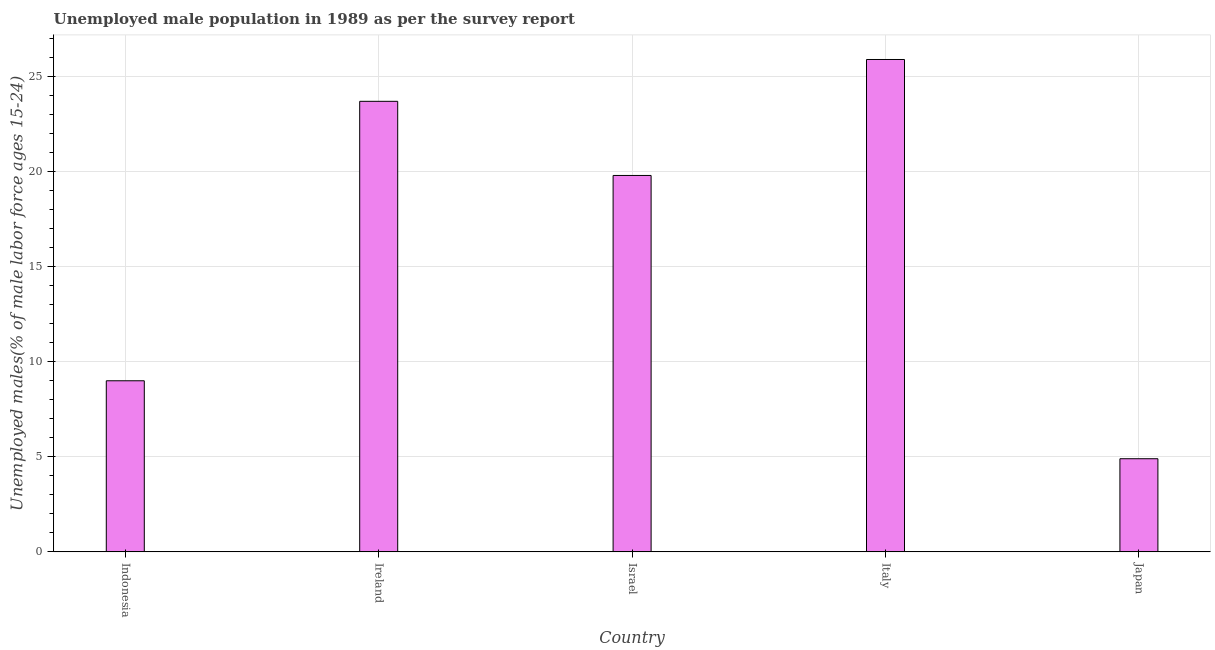Does the graph contain any zero values?
Offer a terse response. No. What is the title of the graph?
Provide a short and direct response. Unemployed male population in 1989 as per the survey report. What is the label or title of the X-axis?
Your response must be concise. Country. What is the label or title of the Y-axis?
Make the answer very short. Unemployed males(% of male labor force ages 15-24). Across all countries, what is the maximum unemployed male youth?
Offer a terse response. 25.9. Across all countries, what is the minimum unemployed male youth?
Give a very brief answer. 4.9. In which country was the unemployed male youth maximum?
Your answer should be compact. Italy. In which country was the unemployed male youth minimum?
Make the answer very short. Japan. What is the sum of the unemployed male youth?
Provide a short and direct response. 83.3. What is the difference between the unemployed male youth in Israel and Italy?
Make the answer very short. -6.1. What is the average unemployed male youth per country?
Offer a very short reply. 16.66. What is the median unemployed male youth?
Make the answer very short. 19.8. What is the ratio of the unemployed male youth in Israel to that in Japan?
Provide a short and direct response. 4.04. Is the unemployed male youth in Ireland less than that in Israel?
Offer a very short reply. No. What is the difference between the highest and the second highest unemployed male youth?
Give a very brief answer. 2.2. In how many countries, is the unemployed male youth greater than the average unemployed male youth taken over all countries?
Provide a succinct answer. 3. How many countries are there in the graph?
Offer a very short reply. 5. What is the Unemployed males(% of male labor force ages 15-24) in Indonesia?
Your answer should be very brief. 9. What is the Unemployed males(% of male labor force ages 15-24) of Ireland?
Offer a terse response. 23.7. What is the Unemployed males(% of male labor force ages 15-24) of Israel?
Provide a short and direct response. 19.8. What is the Unemployed males(% of male labor force ages 15-24) of Italy?
Provide a short and direct response. 25.9. What is the Unemployed males(% of male labor force ages 15-24) in Japan?
Ensure brevity in your answer.  4.9. What is the difference between the Unemployed males(% of male labor force ages 15-24) in Indonesia and Ireland?
Your answer should be compact. -14.7. What is the difference between the Unemployed males(% of male labor force ages 15-24) in Indonesia and Italy?
Your answer should be very brief. -16.9. What is the difference between the Unemployed males(% of male labor force ages 15-24) in Indonesia and Japan?
Your answer should be very brief. 4.1. What is the difference between the Unemployed males(% of male labor force ages 15-24) in Ireland and Italy?
Your answer should be very brief. -2.2. What is the difference between the Unemployed males(% of male labor force ages 15-24) in Israel and Italy?
Provide a short and direct response. -6.1. What is the difference between the Unemployed males(% of male labor force ages 15-24) in Israel and Japan?
Offer a terse response. 14.9. What is the difference between the Unemployed males(% of male labor force ages 15-24) in Italy and Japan?
Your response must be concise. 21. What is the ratio of the Unemployed males(% of male labor force ages 15-24) in Indonesia to that in Ireland?
Keep it short and to the point. 0.38. What is the ratio of the Unemployed males(% of male labor force ages 15-24) in Indonesia to that in Israel?
Provide a succinct answer. 0.46. What is the ratio of the Unemployed males(% of male labor force ages 15-24) in Indonesia to that in Italy?
Your answer should be very brief. 0.35. What is the ratio of the Unemployed males(% of male labor force ages 15-24) in Indonesia to that in Japan?
Offer a terse response. 1.84. What is the ratio of the Unemployed males(% of male labor force ages 15-24) in Ireland to that in Israel?
Your answer should be very brief. 1.2. What is the ratio of the Unemployed males(% of male labor force ages 15-24) in Ireland to that in Italy?
Provide a succinct answer. 0.92. What is the ratio of the Unemployed males(% of male labor force ages 15-24) in Ireland to that in Japan?
Keep it short and to the point. 4.84. What is the ratio of the Unemployed males(% of male labor force ages 15-24) in Israel to that in Italy?
Keep it short and to the point. 0.76. What is the ratio of the Unemployed males(% of male labor force ages 15-24) in Israel to that in Japan?
Provide a succinct answer. 4.04. What is the ratio of the Unemployed males(% of male labor force ages 15-24) in Italy to that in Japan?
Your answer should be compact. 5.29. 